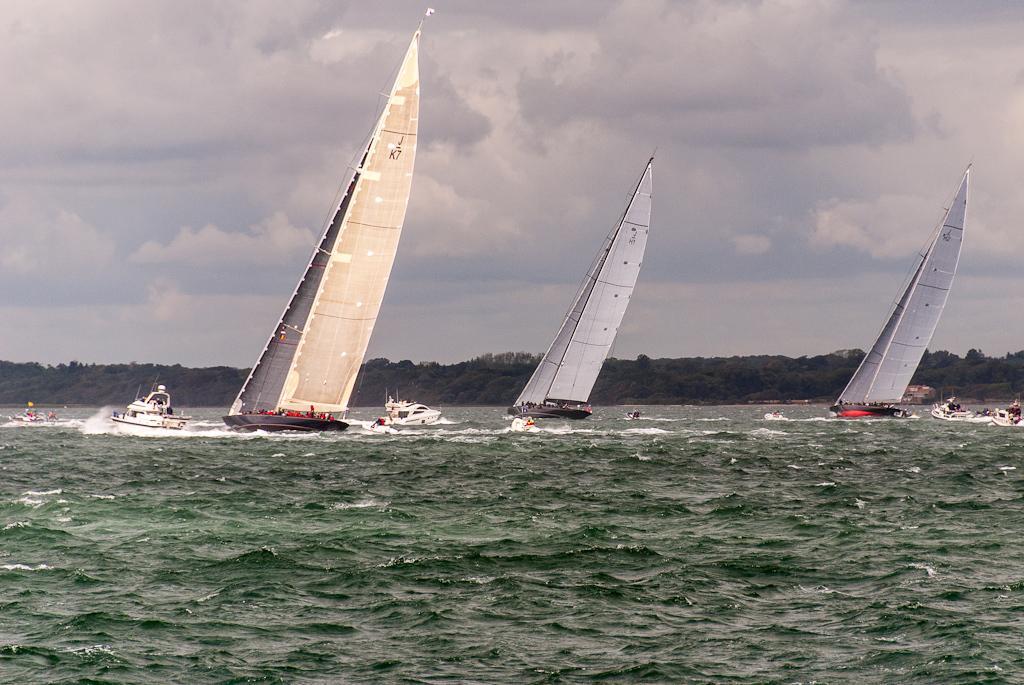In one or two sentences, can you explain what this image depicts? In this image at the bottom there is a beach, and in the beach there are some boats and ships. In the boats and ships there are some people and in the background there are some trees, at the top there is sky. 